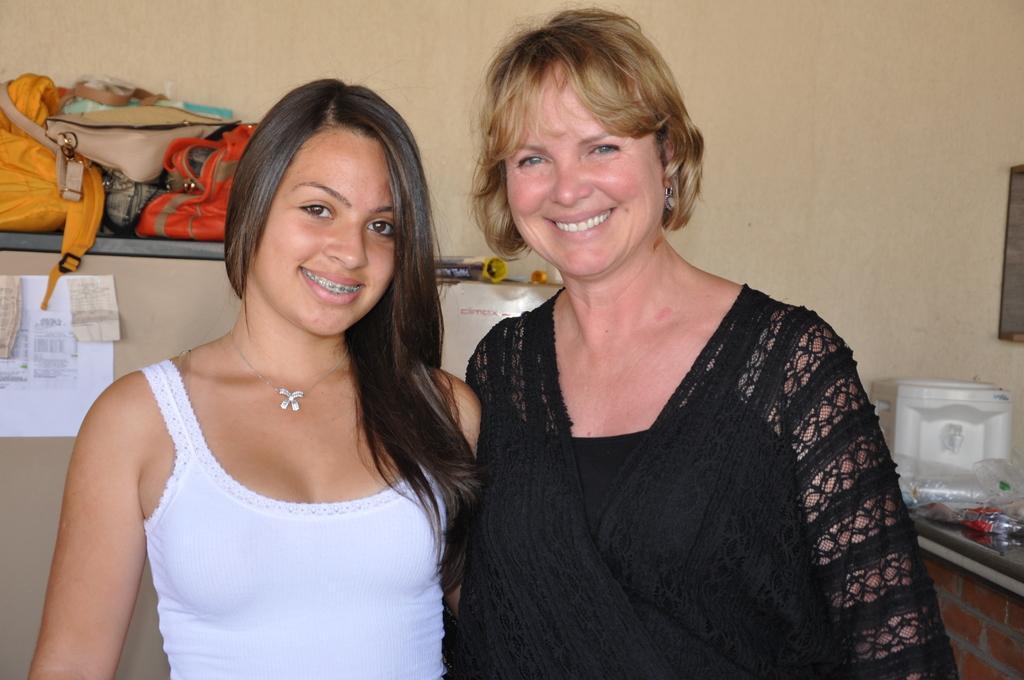Please provide a concise description of this image. This image is clicked in a house. In the front, there are two women. To the right, the woman is wearing black dress. To the left, the women wearing white dress. In the background, there is a wall in cream color and some bags are kept on the desk. And a paper is stuck on the wall. 